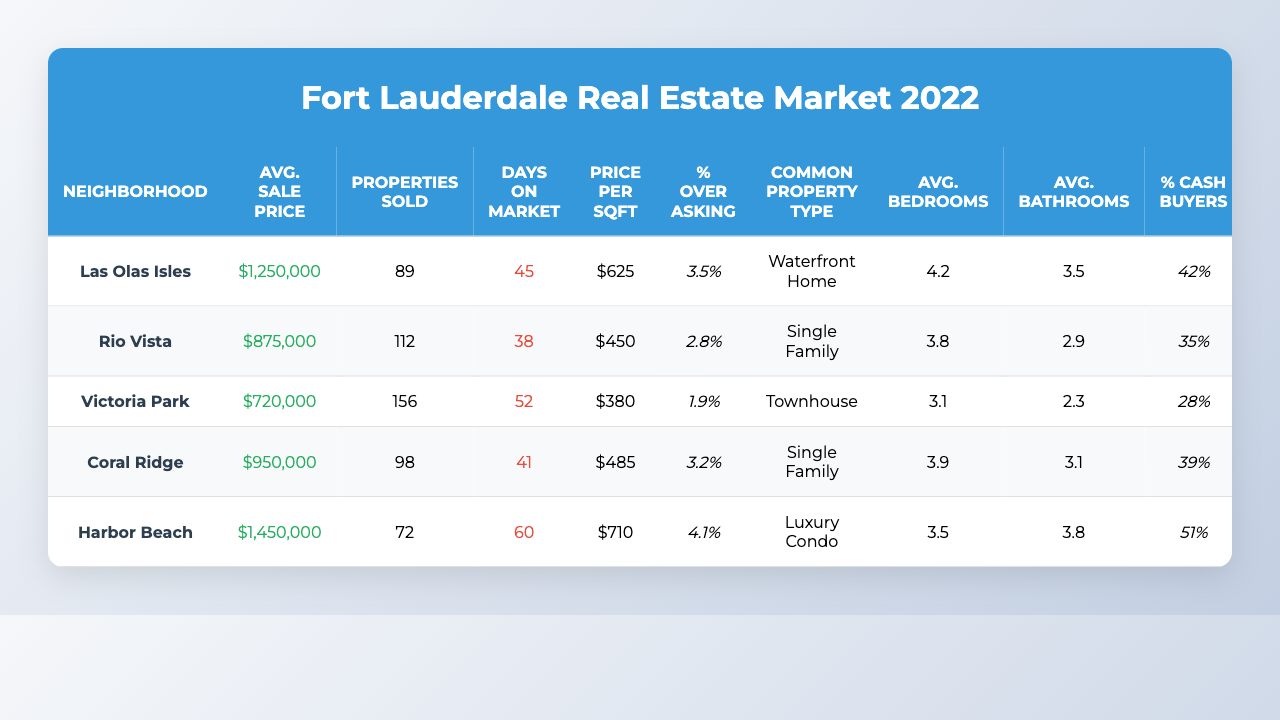What is the average sale price of properties in Rio Vista? The average sale price for Rio Vista is listed in the table as $875,000.
Answer: $875,000 How many properties were sold in Victoria Park? The number of properties sold in Victoria Park is provided in the table as 156.
Answer: 156 Which neighborhood has the highest average sale price? By comparing the average sale prices in the table, Harbor Beach has the highest average sale price at $1,450,000.
Answer: Harbor Beach What is the average number of bedrooms in Coral Ridge? The average number of bedrooms in Coral Ridge is listed in the table as 3.9.
Answer: 3.9 What is the difference in the average sale price between Las Olas Isles and Coral Ridge? The average sale price for Las Olas Isles is $1,250,000 and for Coral Ridge is $950,000. The difference is $1,250,000 - $950,000 = $300,000.
Answer: $300,000 Is the most common property type in Victoria Park a single-family home? The table states that the most common property type in Victoria Park is a townhouse, so the answer is no.
Answer: No What is the average days on the market for all neighborhoods combined? To find the average, we sum the days on the market: 45 + 38 + 52 + 41 + 60 = 236. There are 5 neighborhoods, so we divide by 5: 236 / 5 = 47.2 days.
Answer: 47.2 days Which neighborhood has the highest percentage of cash buyers? We look at the percent cash buyers column and find that Harbor Beach has the highest percentage at 51%.
Answer: Harbor Beach How does the average price per square foot in Las Olas Isles compare to that in Victoria Park? The average price per square foot in Las Olas Isles is $625, while in Victoria Park it is $380. The difference is $625 - $380 = $245.
Answer: $245 Is it true that the average number of bathrooms in Rio Vista is less than 3? The average number of bathrooms in Rio Vista is 2.9, which is less than 3, so the answer is yes.
Answer: Yes 